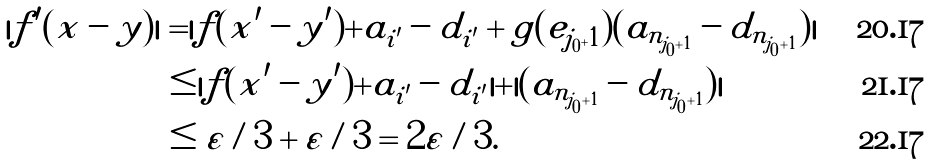Convert formula to latex. <formula><loc_0><loc_0><loc_500><loc_500>| f ^ { \prime } ( x - y ) | & = | f ( x ^ { \prime } - y ^ { \prime } ) + a _ { i ^ { \prime } } - d _ { i ^ { \prime } } + g ( e _ { j _ { 0 } + 1 } ) ( a _ { n _ { j _ { 0 } + 1 } } - d _ { n _ { j _ { 0 } + 1 } } ) | \\ & \leq | f ( x ^ { \prime } - y ^ { \prime } ) + a _ { i ^ { \prime } } - d _ { i ^ { \prime } } | + | ( a _ { n _ { j _ { 0 } + 1 } } - d _ { n _ { j _ { 0 } + 1 } } ) | \\ & \leq \varepsilon / 3 + \varepsilon / 3 = 2 \varepsilon / 3 .</formula> 